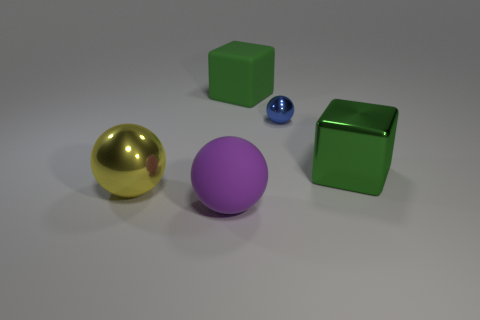Add 1 big spheres. How many objects exist? 6 Subtract all blocks. How many objects are left? 3 Add 4 big matte objects. How many big matte objects are left? 6 Add 1 tiny gray rubber cylinders. How many tiny gray rubber cylinders exist? 1 Subtract 0 blue blocks. How many objects are left? 5 Subtract all large blue matte blocks. Subtract all metal blocks. How many objects are left? 4 